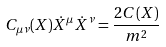<formula> <loc_0><loc_0><loc_500><loc_500>C _ { \mu \nu } ( X ) \dot { X } ^ { \mu } \dot { X } ^ { \nu } = \frac { 2 C ( X ) } { m ^ { 2 } }</formula> 